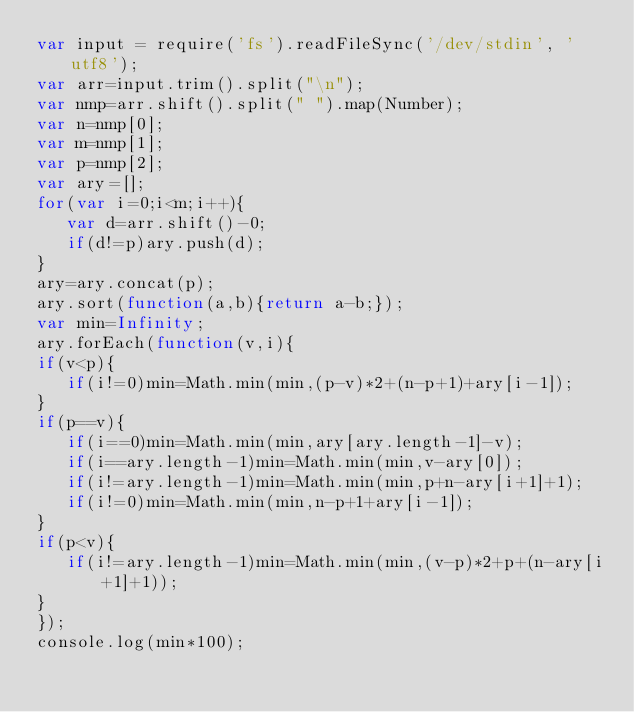Convert code to text. <code><loc_0><loc_0><loc_500><loc_500><_JavaScript_>var input = require('fs').readFileSync('/dev/stdin', 'utf8');
var arr=input.trim().split("\n");
var nmp=arr.shift().split(" ").map(Number);
var n=nmp[0];
var m=nmp[1];
var p=nmp[2];
var ary=[];
for(var i=0;i<m;i++){
   var d=arr.shift()-0;
   if(d!=p)ary.push(d);
}
ary=ary.concat(p);
ary.sort(function(a,b){return a-b;});
var min=Infinity;
ary.forEach(function(v,i){
if(v<p){
   if(i!=0)min=Math.min(min,(p-v)*2+(n-p+1)+ary[i-1]);
}
if(p==v){
   if(i==0)min=Math.min(min,ary[ary.length-1]-v);
   if(i==ary.length-1)min=Math.min(min,v-ary[0]);
   if(i!=ary.length-1)min=Math.min(min,p+n-ary[i+1]+1);
   if(i!=0)min=Math.min(min,n-p+1+ary[i-1]);
}
if(p<v){
   if(i!=ary.length-1)min=Math.min(min,(v-p)*2+p+(n-ary[i+1]+1));
}
});
console.log(min*100);</code> 